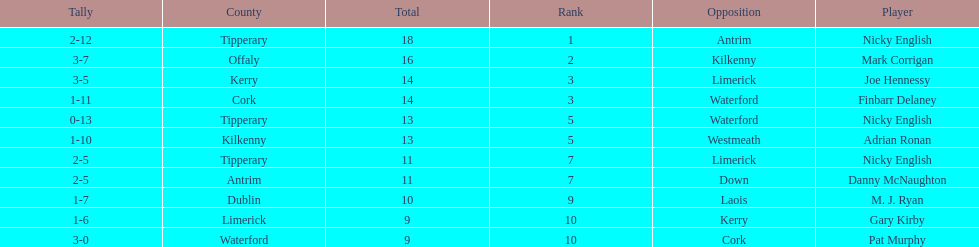What is the least total on the list? 9. 